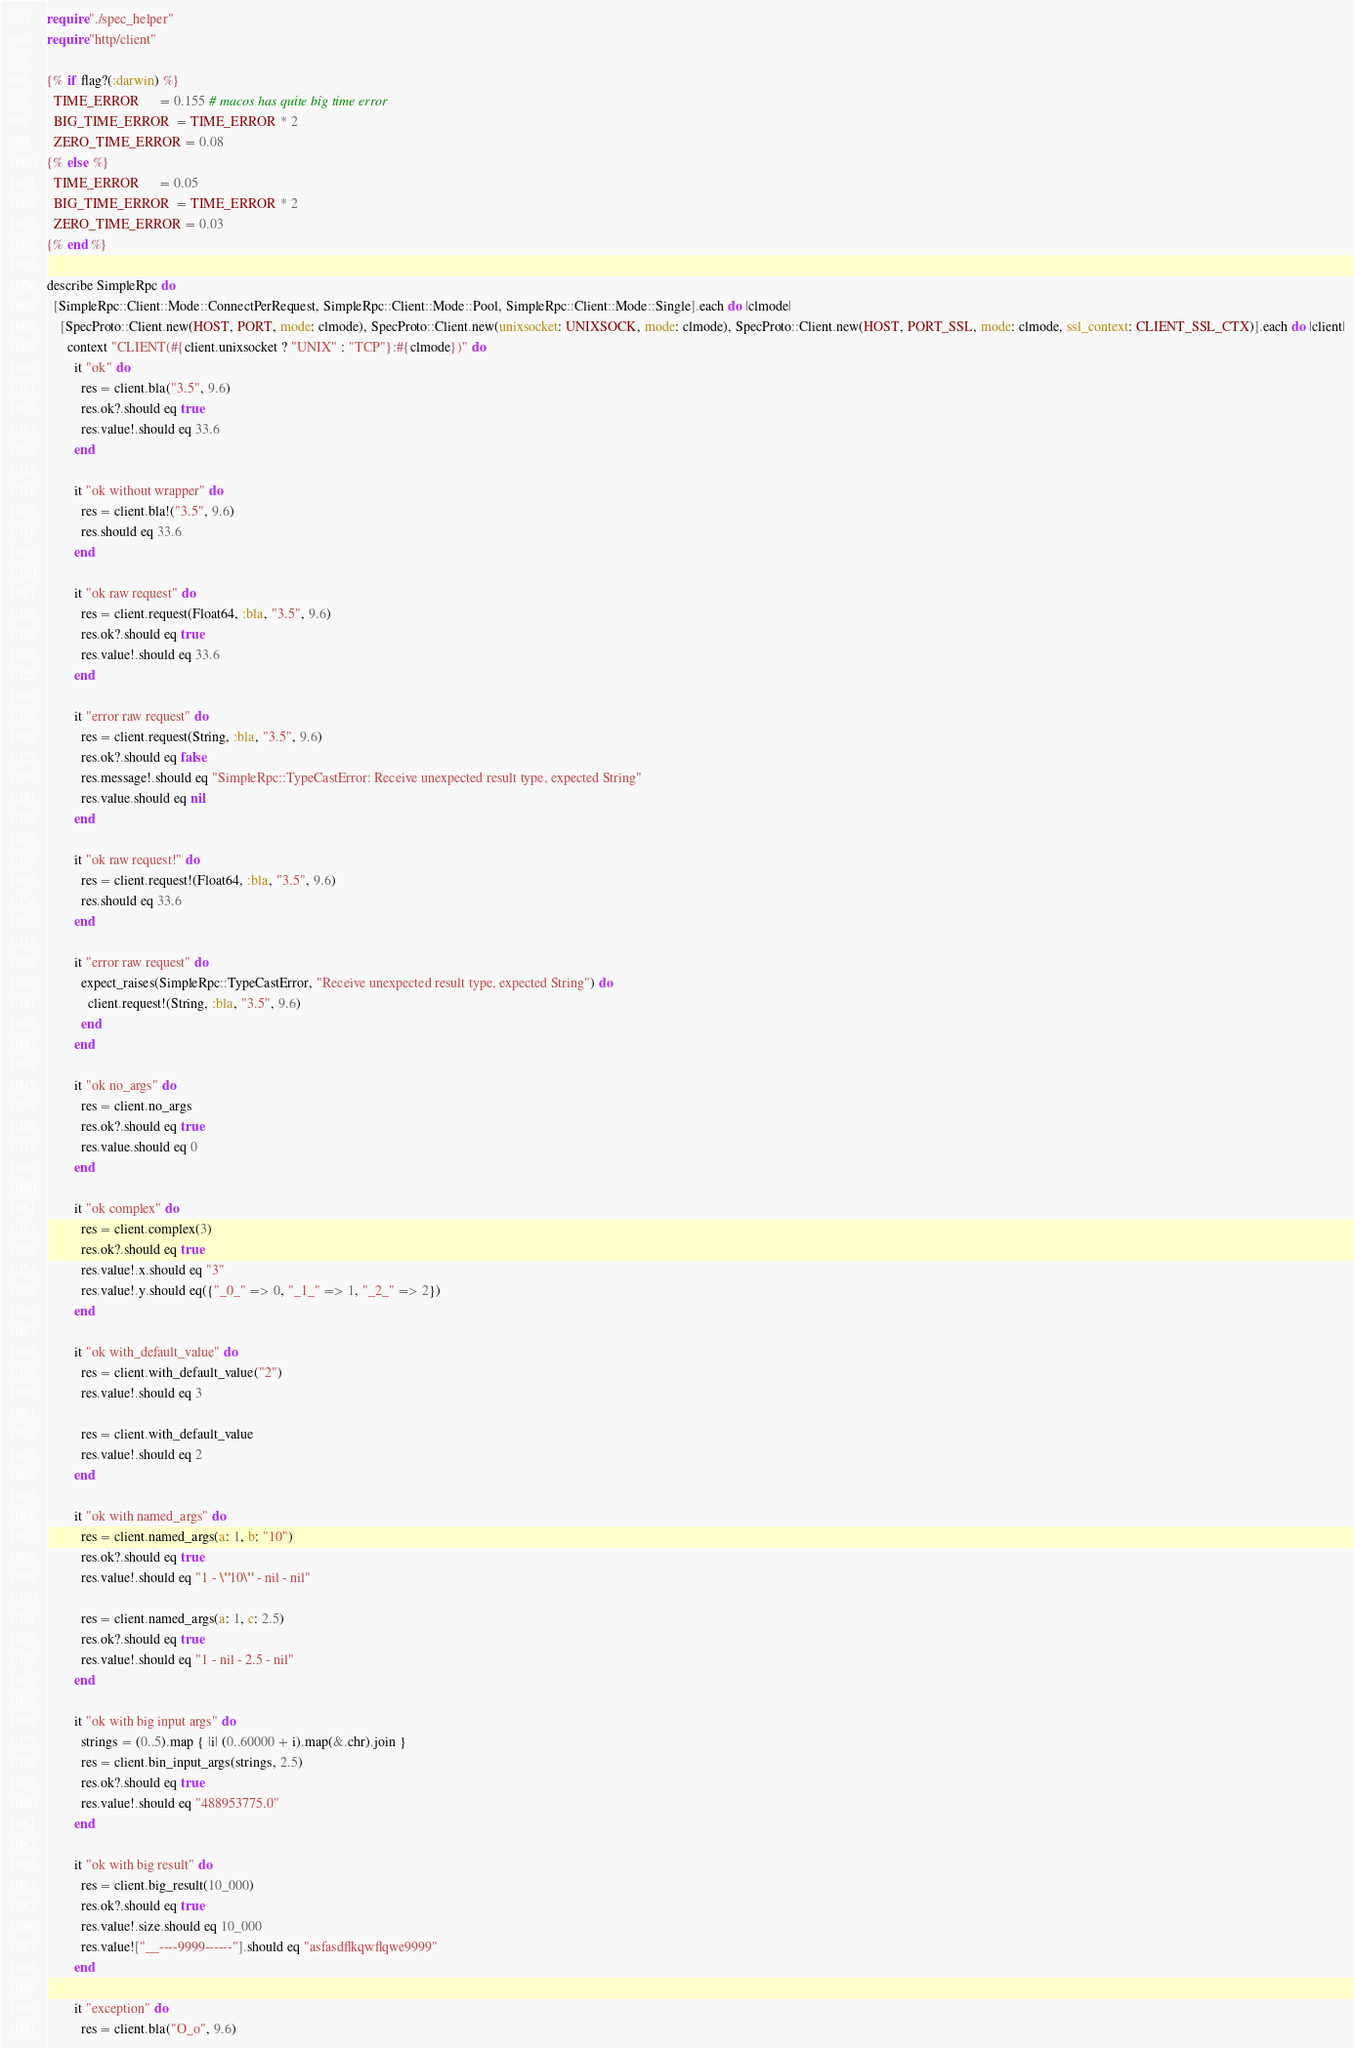<code> <loc_0><loc_0><loc_500><loc_500><_Crystal_>require "./spec_helper"
require "http/client"

{% if flag?(:darwin) %}
  TIME_ERROR      = 0.155 # macos has quite big time error
  BIG_TIME_ERROR  = TIME_ERROR * 2
  ZERO_TIME_ERROR = 0.08
{% else %}
  TIME_ERROR      = 0.05
  BIG_TIME_ERROR  = TIME_ERROR * 2
  ZERO_TIME_ERROR = 0.03
{% end %}

describe SimpleRpc do
  [SimpleRpc::Client::Mode::ConnectPerRequest, SimpleRpc::Client::Mode::Pool, SimpleRpc::Client::Mode::Single].each do |clmode|
    [SpecProto::Client.new(HOST, PORT, mode: clmode), SpecProto::Client.new(unixsocket: UNIXSOCK, mode: clmode), SpecProto::Client.new(HOST, PORT_SSL, mode: clmode, ssl_context: CLIENT_SSL_CTX)].each do |client|
      context "CLIENT(#{client.unixsocket ? "UNIX" : "TCP"}:#{clmode})" do
        it "ok" do
          res = client.bla("3.5", 9.6)
          res.ok?.should eq true
          res.value!.should eq 33.6
        end

        it "ok without wrapper" do
          res = client.bla!("3.5", 9.6)
          res.should eq 33.6
        end

        it "ok raw request" do
          res = client.request(Float64, :bla, "3.5", 9.6)
          res.ok?.should eq true
          res.value!.should eq 33.6
        end

        it "error raw request" do
          res = client.request(String, :bla, "3.5", 9.6)
          res.ok?.should eq false
          res.message!.should eq "SimpleRpc::TypeCastError: Receive unexpected result type, expected String"
          res.value.should eq nil
        end

        it "ok raw request!" do
          res = client.request!(Float64, :bla, "3.5", 9.6)
          res.should eq 33.6
        end

        it "error raw request" do
          expect_raises(SimpleRpc::TypeCastError, "Receive unexpected result type, expected String") do
            client.request!(String, :bla, "3.5", 9.6)
          end
        end

        it "ok no_args" do
          res = client.no_args
          res.ok?.should eq true
          res.value.should eq 0
        end

        it "ok complex" do
          res = client.complex(3)
          res.ok?.should eq true
          res.value!.x.should eq "3"
          res.value!.y.should eq({"_0_" => 0, "_1_" => 1, "_2_" => 2})
        end

        it "ok with_default_value" do
          res = client.with_default_value("2")
          res.value!.should eq 3

          res = client.with_default_value
          res.value!.should eq 2
        end

        it "ok with named_args" do
          res = client.named_args(a: 1, b: "10")
          res.ok?.should eq true
          res.value!.should eq "1 - \"10\" - nil - nil"

          res = client.named_args(a: 1, c: 2.5)
          res.ok?.should eq true
          res.value!.should eq "1 - nil - 2.5 - nil"
        end

        it "ok with big input args" do
          strings = (0..5).map { |i| (0..60000 + i).map(&.chr).join }
          res = client.bin_input_args(strings, 2.5)
          res.ok?.should eq true
          res.value!.should eq "488953775.0"
        end

        it "ok with big result" do
          res = client.big_result(10_000)
          res.ok?.should eq true
          res.value!.size.should eq 10_000
          res.value!["__----9999------"].should eq "asfasdflkqwflqwe9999"
        end

        it "exception" do
          res = client.bla("O_o", 9.6)</code> 